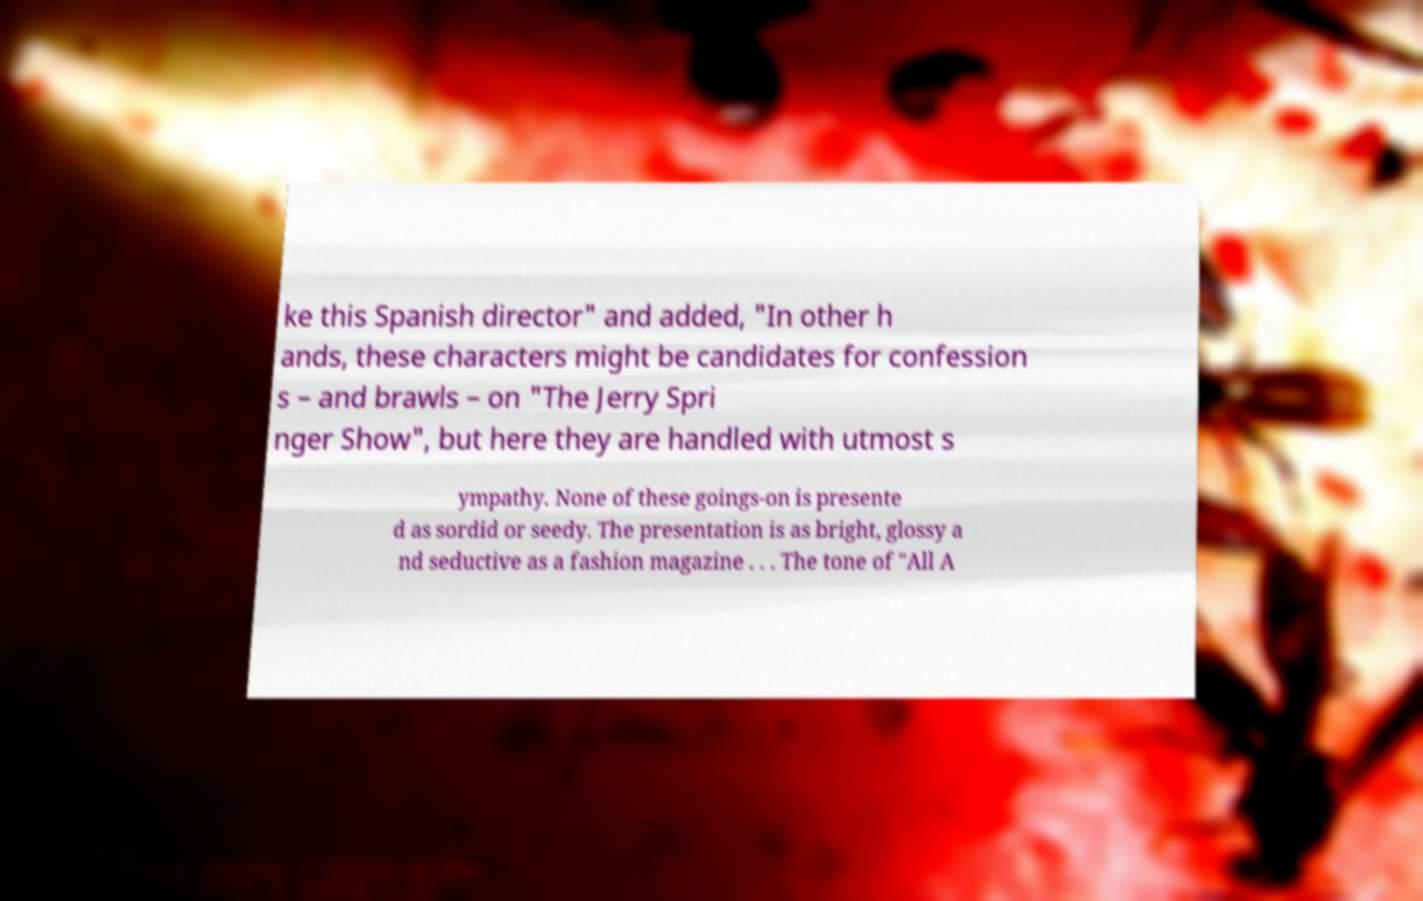For documentation purposes, I need the text within this image transcribed. Could you provide that? ke this Spanish director" and added, "In other h ands, these characters might be candidates for confession s – and brawls – on "The Jerry Spri nger Show", but here they are handled with utmost s ympathy. None of these goings-on is presente d as sordid or seedy. The presentation is as bright, glossy a nd seductive as a fashion magazine . . . The tone of "All A 